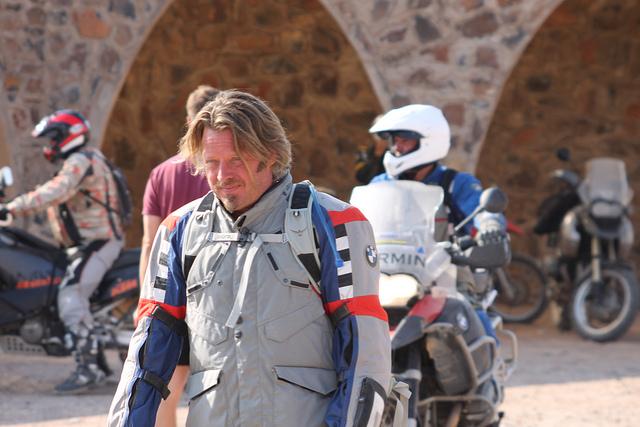Does this man have long hair?
Answer briefly. Yes. Do you see something on the men's heads?
Quick response, please. Yes. What is behind the man?
Short answer required. Motorcycle. 